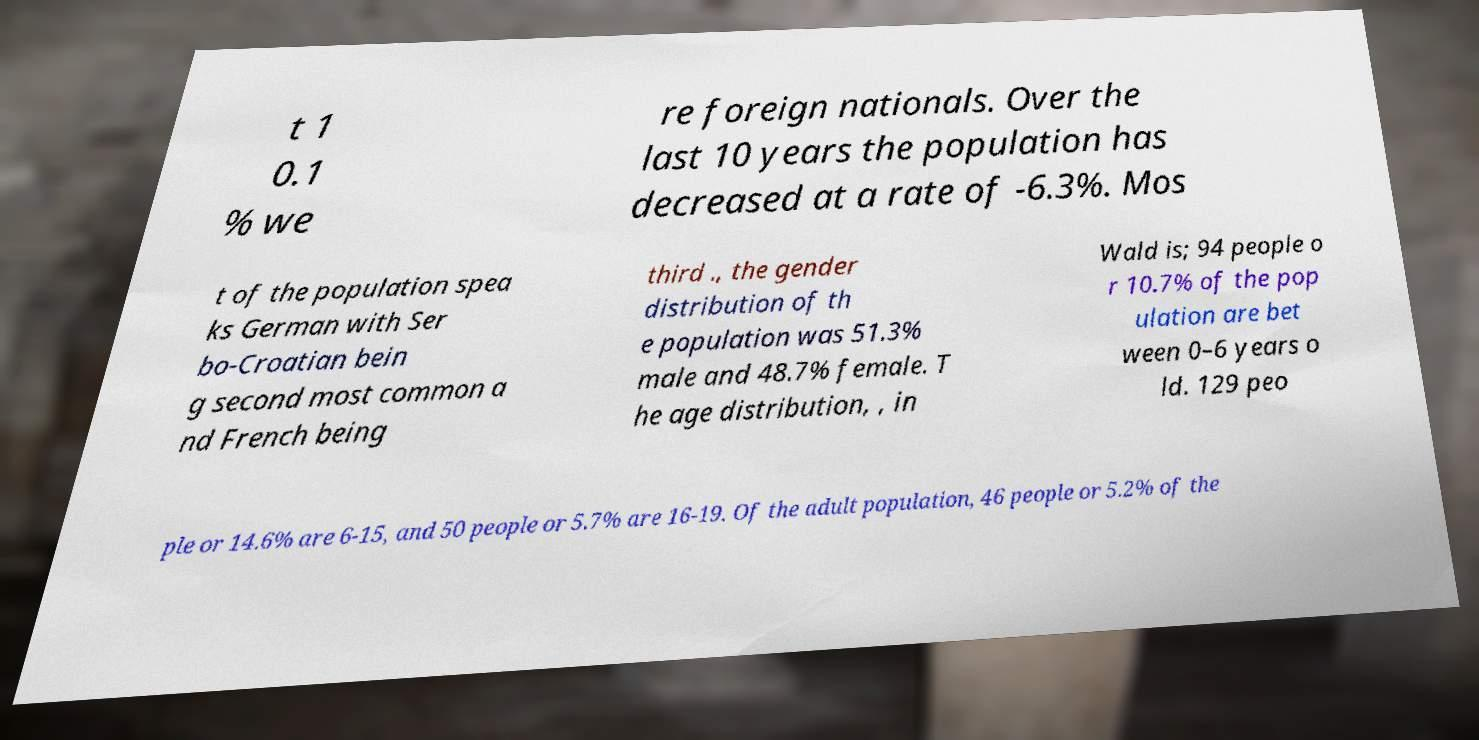For documentation purposes, I need the text within this image transcribed. Could you provide that? t 1 0.1 % we re foreign nationals. Over the last 10 years the population has decreased at a rate of -6.3%. Mos t of the population spea ks German with Ser bo-Croatian bein g second most common a nd French being third ., the gender distribution of th e population was 51.3% male and 48.7% female. T he age distribution, , in Wald is; 94 people o r 10.7% of the pop ulation are bet ween 0–6 years o ld. 129 peo ple or 14.6% are 6-15, and 50 people or 5.7% are 16-19. Of the adult population, 46 people or 5.2% of the 